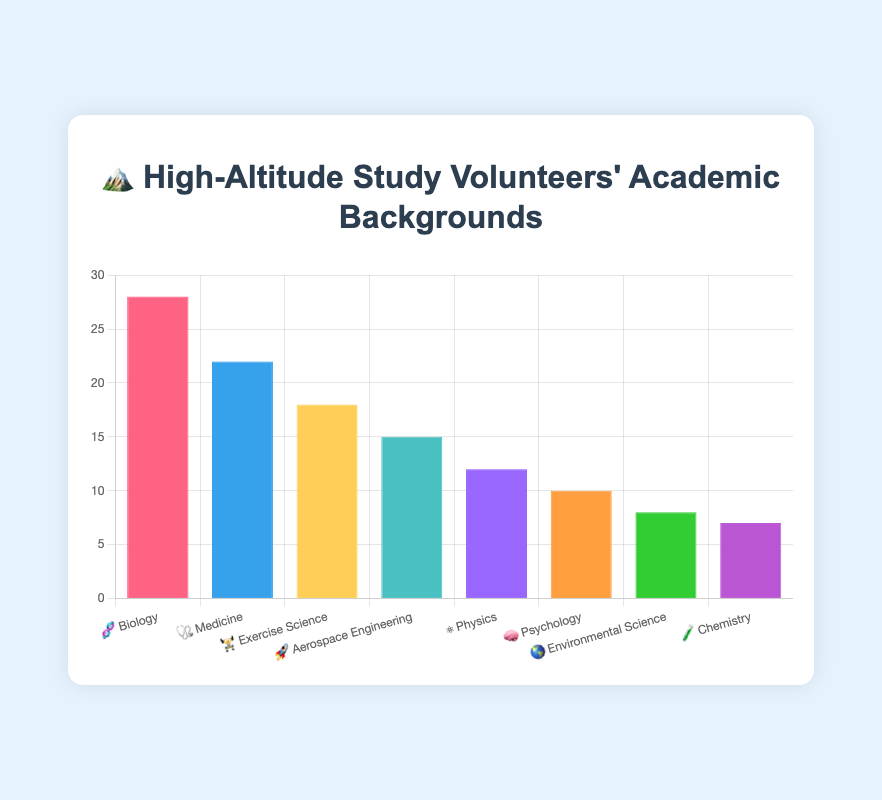What's the most common academic background among volunteers? The highest bar represents "🧬 Biology" with 28 volunteers. Therefore, Biology is the most common academic background.
Answer: Biology What is the total number of volunteers from Medicine and Aerospace Engineering backgrounds? The bar for Medicine shows 22 volunteers, and the bar for Aerospace Engineering shows 15 volunteers. Summing these gives 22 + 15 = 37.
Answer: 37 Which academic background has fewer volunteers: Environmental Science or Chemistry? The bar for Environmental Science shows 8 volunteers, while the bar for Chemistry shows 7 volunteers. Therefore, Chemistry has fewer volunteers.
Answer: Chemistry How many more volunteers have a background in Biology compared to Physics? The bar for Biology shows 28 volunteers, while the bar for Physics shows 12 volunteers. The difference is 28 - 12 = 16.
Answer: 16 What's the least common academic background among the volunteers? The shortest bar represents "🧪 Chemistry" with 7 volunteers. Therefore, Chemistry is the least common academic background.
Answer: Chemistry If we combine the volunteers from Exercise Science and Psychology, how many do we have? The bar for Exercise Science shows 18 volunteers, and the bar for Psychology shows 10 volunteers. Summing these gives 18 + 10 = 28.
Answer: 28 What is the average number of volunteers across all academic backgrounds? Sum of all volunteers: 28 (Biology) + 22 (Medicine) + 18 (Exercise Science) + 15 (Aerospace Engineering) + 12 (Physics) + 10 (Psychology) + 8 (Environmental Science) + 7 (Chemistry) = 120. There are 8 academic backgrounds. Therefore, the average is 120 / 8 = 15.
Answer: 15 Which academic background has the second highest number of volunteers? The highest number of volunteers is for Biology (28), and the second highest bar represents "🩺 Medicine" with 22 volunteers.
Answer: Medicine Between Medicine and Physics, how many more volunteers does Medicine have? The bar for Medicine shows 22 volunteers, while the bar for Physics shows 12 volunteers. The difference is 22 - 12 = 10.
Answer: 10 What is the combined volunteer count for all science-related fields (Biology, Physics, Environmental Science, Chemistry)? Summing the volunteer counts for Biology (28), Physics (12), Environmental Science (8), and Chemistry (7) gives 28 + 12 + 8 + 7 = 55.
Answer: 55 